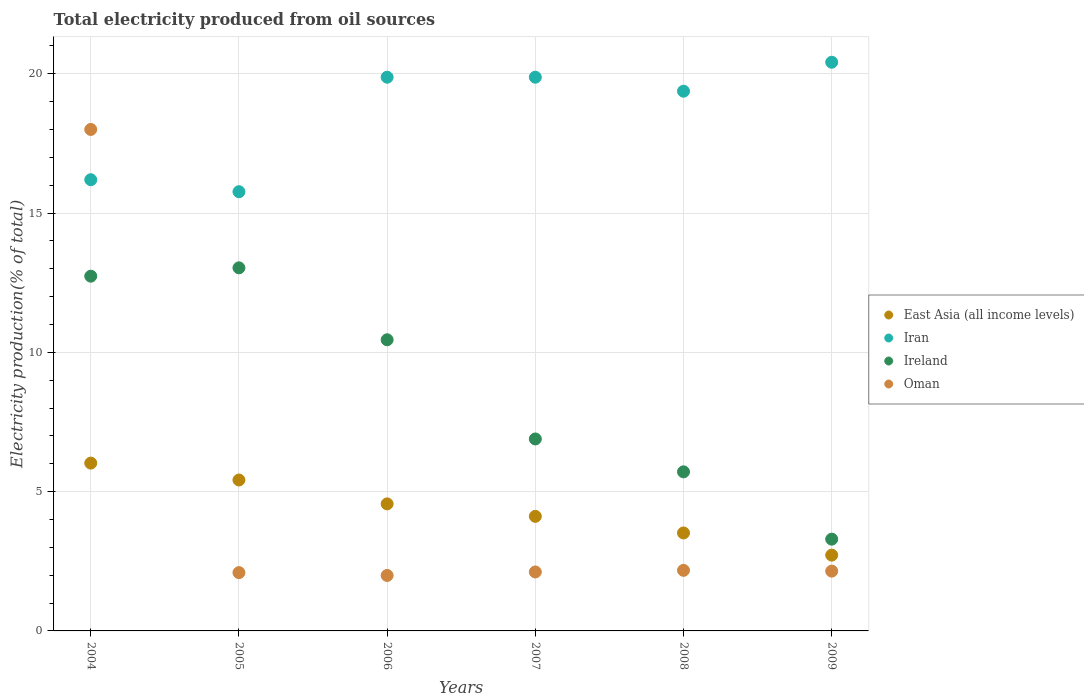What is the total electricity produced in Oman in 2009?
Provide a short and direct response. 2.15. Across all years, what is the maximum total electricity produced in Ireland?
Make the answer very short. 13.03. Across all years, what is the minimum total electricity produced in Iran?
Keep it short and to the point. 15.77. In which year was the total electricity produced in East Asia (all income levels) maximum?
Offer a terse response. 2004. In which year was the total electricity produced in Oman minimum?
Offer a very short reply. 2006. What is the total total electricity produced in Oman in the graph?
Your answer should be compact. 28.52. What is the difference between the total electricity produced in Oman in 2005 and that in 2007?
Make the answer very short. -0.02. What is the difference between the total electricity produced in Oman in 2006 and the total electricity produced in Ireland in 2009?
Your answer should be very brief. -1.3. What is the average total electricity produced in Iran per year?
Keep it short and to the point. 18.58. In the year 2007, what is the difference between the total electricity produced in Iran and total electricity produced in East Asia (all income levels)?
Provide a succinct answer. 15.76. In how many years, is the total electricity produced in Ireland greater than 2 %?
Make the answer very short. 6. What is the ratio of the total electricity produced in Iran in 2005 to that in 2009?
Provide a short and direct response. 0.77. Is the total electricity produced in Ireland in 2004 less than that in 2008?
Make the answer very short. No. What is the difference between the highest and the second highest total electricity produced in Oman?
Your answer should be compact. 15.83. What is the difference between the highest and the lowest total electricity produced in Iran?
Ensure brevity in your answer.  4.65. Is it the case that in every year, the sum of the total electricity produced in Iran and total electricity produced in East Asia (all income levels)  is greater than the total electricity produced in Oman?
Offer a very short reply. Yes. Does the total electricity produced in Iran monotonically increase over the years?
Offer a very short reply. No. Is the total electricity produced in East Asia (all income levels) strictly greater than the total electricity produced in Ireland over the years?
Your answer should be very brief. No. How many dotlines are there?
Provide a short and direct response. 4. Does the graph contain any zero values?
Provide a succinct answer. No. Does the graph contain grids?
Your response must be concise. Yes. Where does the legend appear in the graph?
Give a very brief answer. Center right. How many legend labels are there?
Keep it short and to the point. 4. How are the legend labels stacked?
Keep it short and to the point. Vertical. What is the title of the graph?
Your response must be concise. Total electricity produced from oil sources. What is the Electricity production(% of total) in East Asia (all income levels) in 2004?
Offer a very short reply. 6.02. What is the Electricity production(% of total) of Iran in 2004?
Ensure brevity in your answer.  16.2. What is the Electricity production(% of total) in Ireland in 2004?
Your answer should be compact. 12.73. What is the Electricity production(% of total) of Oman in 2004?
Your answer should be compact. 18. What is the Electricity production(% of total) of East Asia (all income levels) in 2005?
Provide a short and direct response. 5.42. What is the Electricity production(% of total) of Iran in 2005?
Keep it short and to the point. 15.77. What is the Electricity production(% of total) in Ireland in 2005?
Your response must be concise. 13.03. What is the Electricity production(% of total) in Oman in 2005?
Provide a short and direct response. 2.09. What is the Electricity production(% of total) in East Asia (all income levels) in 2006?
Offer a very short reply. 4.56. What is the Electricity production(% of total) of Iran in 2006?
Give a very brief answer. 19.88. What is the Electricity production(% of total) in Ireland in 2006?
Give a very brief answer. 10.45. What is the Electricity production(% of total) of Oman in 2006?
Provide a succinct answer. 1.99. What is the Electricity production(% of total) in East Asia (all income levels) in 2007?
Your answer should be very brief. 4.11. What is the Electricity production(% of total) of Iran in 2007?
Give a very brief answer. 19.88. What is the Electricity production(% of total) of Ireland in 2007?
Give a very brief answer. 6.89. What is the Electricity production(% of total) in Oman in 2007?
Keep it short and to the point. 2.12. What is the Electricity production(% of total) of East Asia (all income levels) in 2008?
Offer a terse response. 3.52. What is the Electricity production(% of total) in Iran in 2008?
Your answer should be very brief. 19.37. What is the Electricity production(% of total) of Ireland in 2008?
Offer a terse response. 5.71. What is the Electricity production(% of total) of Oman in 2008?
Your answer should be very brief. 2.17. What is the Electricity production(% of total) in East Asia (all income levels) in 2009?
Keep it short and to the point. 2.72. What is the Electricity production(% of total) in Iran in 2009?
Your answer should be compact. 20.41. What is the Electricity production(% of total) in Ireland in 2009?
Your answer should be very brief. 3.29. What is the Electricity production(% of total) in Oman in 2009?
Keep it short and to the point. 2.15. Across all years, what is the maximum Electricity production(% of total) of East Asia (all income levels)?
Your answer should be very brief. 6.02. Across all years, what is the maximum Electricity production(% of total) of Iran?
Give a very brief answer. 20.41. Across all years, what is the maximum Electricity production(% of total) in Ireland?
Keep it short and to the point. 13.03. Across all years, what is the maximum Electricity production(% of total) of Oman?
Give a very brief answer. 18. Across all years, what is the minimum Electricity production(% of total) of East Asia (all income levels)?
Offer a very short reply. 2.72. Across all years, what is the minimum Electricity production(% of total) of Iran?
Your answer should be very brief. 15.77. Across all years, what is the minimum Electricity production(% of total) in Ireland?
Offer a terse response. 3.29. Across all years, what is the minimum Electricity production(% of total) in Oman?
Keep it short and to the point. 1.99. What is the total Electricity production(% of total) of East Asia (all income levels) in the graph?
Provide a short and direct response. 26.35. What is the total Electricity production(% of total) of Iran in the graph?
Ensure brevity in your answer.  111.51. What is the total Electricity production(% of total) of Ireland in the graph?
Keep it short and to the point. 52.12. What is the total Electricity production(% of total) of Oman in the graph?
Make the answer very short. 28.52. What is the difference between the Electricity production(% of total) of East Asia (all income levels) in 2004 and that in 2005?
Make the answer very short. 0.61. What is the difference between the Electricity production(% of total) in Iran in 2004 and that in 2005?
Provide a succinct answer. 0.43. What is the difference between the Electricity production(% of total) of Ireland in 2004 and that in 2005?
Provide a succinct answer. -0.3. What is the difference between the Electricity production(% of total) of Oman in 2004 and that in 2005?
Your response must be concise. 15.91. What is the difference between the Electricity production(% of total) in East Asia (all income levels) in 2004 and that in 2006?
Offer a terse response. 1.46. What is the difference between the Electricity production(% of total) in Iran in 2004 and that in 2006?
Your answer should be very brief. -3.68. What is the difference between the Electricity production(% of total) of Ireland in 2004 and that in 2006?
Ensure brevity in your answer.  2.28. What is the difference between the Electricity production(% of total) of Oman in 2004 and that in 2006?
Offer a very short reply. 16.01. What is the difference between the Electricity production(% of total) in East Asia (all income levels) in 2004 and that in 2007?
Your answer should be compact. 1.91. What is the difference between the Electricity production(% of total) in Iran in 2004 and that in 2007?
Offer a very short reply. -3.68. What is the difference between the Electricity production(% of total) in Ireland in 2004 and that in 2007?
Provide a succinct answer. 5.84. What is the difference between the Electricity production(% of total) in Oman in 2004 and that in 2007?
Make the answer very short. 15.88. What is the difference between the Electricity production(% of total) of East Asia (all income levels) in 2004 and that in 2008?
Keep it short and to the point. 2.51. What is the difference between the Electricity production(% of total) in Iran in 2004 and that in 2008?
Your response must be concise. -3.18. What is the difference between the Electricity production(% of total) of Ireland in 2004 and that in 2008?
Your answer should be very brief. 7.02. What is the difference between the Electricity production(% of total) of Oman in 2004 and that in 2008?
Provide a short and direct response. 15.83. What is the difference between the Electricity production(% of total) in East Asia (all income levels) in 2004 and that in 2009?
Make the answer very short. 3.3. What is the difference between the Electricity production(% of total) of Iran in 2004 and that in 2009?
Provide a succinct answer. -4.22. What is the difference between the Electricity production(% of total) in Ireland in 2004 and that in 2009?
Keep it short and to the point. 9.44. What is the difference between the Electricity production(% of total) of Oman in 2004 and that in 2009?
Your response must be concise. 15.85. What is the difference between the Electricity production(% of total) in East Asia (all income levels) in 2005 and that in 2006?
Your answer should be compact. 0.86. What is the difference between the Electricity production(% of total) in Iran in 2005 and that in 2006?
Your answer should be compact. -4.11. What is the difference between the Electricity production(% of total) in Ireland in 2005 and that in 2006?
Keep it short and to the point. 2.58. What is the difference between the Electricity production(% of total) of Oman in 2005 and that in 2006?
Ensure brevity in your answer.  0.1. What is the difference between the Electricity production(% of total) in East Asia (all income levels) in 2005 and that in 2007?
Keep it short and to the point. 1.31. What is the difference between the Electricity production(% of total) in Iran in 2005 and that in 2007?
Your answer should be very brief. -4.11. What is the difference between the Electricity production(% of total) in Ireland in 2005 and that in 2007?
Your answer should be compact. 6.14. What is the difference between the Electricity production(% of total) in Oman in 2005 and that in 2007?
Your answer should be compact. -0.02. What is the difference between the Electricity production(% of total) of East Asia (all income levels) in 2005 and that in 2008?
Keep it short and to the point. 1.9. What is the difference between the Electricity production(% of total) of Iran in 2005 and that in 2008?
Offer a terse response. -3.61. What is the difference between the Electricity production(% of total) of Ireland in 2005 and that in 2008?
Provide a short and direct response. 7.32. What is the difference between the Electricity production(% of total) of Oman in 2005 and that in 2008?
Your answer should be compact. -0.08. What is the difference between the Electricity production(% of total) in East Asia (all income levels) in 2005 and that in 2009?
Ensure brevity in your answer.  2.7. What is the difference between the Electricity production(% of total) of Iran in 2005 and that in 2009?
Keep it short and to the point. -4.65. What is the difference between the Electricity production(% of total) of Ireland in 2005 and that in 2009?
Make the answer very short. 9.74. What is the difference between the Electricity production(% of total) of Oman in 2005 and that in 2009?
Your answer should be very brief. -0.05. What is the difference between the Electricity production(% of total) in East Asia (all income levels) in 2006 and that in 2007?
Give a very brief answer. 0.45. What is the difference between the Electricity production(% of total) of Iran in 2006 and that in 2007?
Provide a succinct answer. -0. What is the difference between the Electricity production(% of total) of Ireland in 2006 and that in 2007?
Provide a succinct answer. 3.56. What is the difference between the Electricity production(% of total) of Oman in 2006 and that in 2007?
Ensure brevity in your answer.  -0.13. What is the difference between the Electricity production(% of total) in East Asia (all income levels) in 2006 and that in 2008?
Ensure brevity in your answer.  1.04. What is the difference between the Electricity production(% of total) of Iran in 2006 and that in 2008?
Keep it short and to the point. 0.5. What is the difference between the Electricity production(% of total) in Ireland in 2006 and that in 2008?
Ensure brevity in your answer.  4.74. What is the difference between the Electricity production(% of total) in Oman in 2006 and that in 2008?
Keep it short and to the point. -0.18. What is the difference between the Electricity production(% of total) in East Asia (all income levels) in 2006 and that in 2009?
Ensure brevity in your answer.  1.84. What is the difference between the Electricity production(% of total) of Iran in 2006 and that in 2009?
Your answer should be very brief. -0.54. What is the difference between the Electricity production(% of total) in Ireland in 2006 and that in 2009?
Your answer should be very brief. 7.16. What is the difference between the Electricity production(% of total) of Oman in 2006 and that in 2009?
Make the answer very short. -0.16. What is the difference between the Electricity production(% of total) of East Asia (all income levels) in 2007 and that in 2008?
Provide a succinct answer. 0.6. What is the difference between the Electricity production(% of total) in Iran in 2007 and that in 2008?
Provide a succinct answer. 0.5. What is the difference between the Electricity production(% of total) in Ireland in 2007 and that in 2008?
Your answer should be very brief. 1.18. What is the difference between the Electricity production(% of total) in Oman in 2007 and that in 2008?
Give a very brief answer. -0.06. What is the difference between the Electricity production(% of total) in East Asia (all income levels) in 2007 and that in 2009?
Your response must be concise. 1.39. What is the difference between the Electricity production(% of total) of Iran in 2007 and that in 2009?
Provide a succinct answer. -0.54. What is the difference between the Electricity production(% of total) in Ireland in 2007 and that in 2009?
Offer a very short reply. 3.6. What is the difference between the Electricity production(% of total) of Oman in 2007 and that in 2009?
Ensure brevity in your answer.  -0.03. What is the difference between the Electricity production(% of total) of East Asia (all income levels) in 2008 and that in 2009?
Offer a terse response. 0.8. What is the difference between the Electricity production(% of total) in Iran in 2008 and that in 2009?
Offer a terse response. -1.04. What is the difference between the Electricity production(% of total) of Ireland in 2008 and that in 2009?
Ensure brevity in your answer.  2.42. What is the difference between the Electricity production(% of total) in Oman in 2008 and that in 2009?
Provide a short and direct response. 0.03. What is the difference between the Electricity production(% of total) in East Asia (all income levels) in 2004 and the Electricity production(% of total) in Iran in 2005?
Offer a terse response. -9.74. What is the difference between the Electricity production(% of total) of East Asia (all income levels) in 2004 and the Electricity production(% of total) of Ireland in 2005?
Offer a terse response. -7.01. What is the difference between the Electricity production(% of total) in East Asia (all income levels) in 2004 and the Electricity production(% of total) in Oman in 2005?
Your answer should be compact. 3.93. What is the difference between the Electricity production(% of total) in Iran in 2004 and the Electricity production(% of total) in Ireland in 2005?
Keep it short and to the point. 3.16. What is the difference between the Electricity production(% of total) in Iran in 2004 and the Electricity production(% of total) in Oman in 2005?
Ensure brevity in your answer.  14.1. What is the difference between the Electricity production(% of total) in Ireland in 2004 and the Electricity production(% of total) in Oman in 2005?
Provide a succinct answer. 10.64. What is the difference between the Electricity production(% of total) of East Asia (all income levels) in 2004 and the Electricity production(% of total) of Iran in 2006?
Provide a short and direct response. -13.85. What is the difference between the Electricity production(% of total) in East Asia (all income levels) in 2004 and the Electricity production(% of total) in Ireland in 2006?
Your answer should be very brief. -4.43. What is the difference between the Electricity production(% of total) of East Asia (all income levels) in 2004 and the Electricity production(% of total) of Oman in 2006?
Give a very brief answer. 4.03. What is the difference between the Electricity production(% of total) in Iran in 2004 and the Electricity production(% of total) in Ireland in 2006?
Offer a terse response. 5.75. What is the difference between the Electricity production(% of total) of Iran in 2004 and the Electricity production(% of total) of Oman in 2006?
Offer a terse response. 14.21. What is the difference between the Electricity production(% of total) in Ireland in 2004 and the Electricity production(% of total) in Oman in 2006?
Make the answer very short. 10.74. What is the difference between the Electricity production(% of total) of East Asia (all income levels) in 2004 and the Electricity production(% of total) of Iran in 2007?
Give a very brief answer. -13.85. What is the difference between the Electricity production(% of total) in East Asia (all income levels) in 2004 and the Electricity production(% of total) in Ireland in 2007?
Your answer should be very brief. -0.87. What is the difference between the Electricity production(% of total) of East Asia (all income levels) in 2004 and the Electricity production(% of total) of Oman in 2007?
Ensure brevity in your answer.  3.91. What is the difference between the Electricity production(% of total) of Iran in 2004 and the Electricity production(% of total) of Ireland in 2007?
Provide a succinct answer. 9.31. What is the difference between the Electricity production(% of total) in Iran in 2004 and the Electricity production(% of total) in Oman in 2007?
Your answer should be very brief. 14.08. What is the difference between the Electricity production(% of total) of Ireland in 2004 and the Electricity production(% of total) of Oman in 2007?
Keep it short and to the point. 10.62. What is the difference between the Electricity production(% of total) in East Asia (all income levels) in 2004 and the Electricity production(% of total) in Iran in 2008?
Ensure brevity in your answer.  -13.35. What is the difference between the Electricity production(% of total) of East Asia (all income levels) in 2004 and the Electricity production(% of total) of Ireland in 2008?
Provide a succinct answer. 0.31. What is the difference between the Electricity production(% of total) of East Asia (all income levels) in 2004 and the Electricity production(% of total) of Oman in 2008?
Your answer should be compact. 3.85. What is the difference between the Electricity production(% of total) of Iran in 2004 and the Electricity production(% of total) of Ireland in 2008?
Provide a succinct answer. 10.49. What is the difference between the Electricity production(% of total) of Iran in 2004 and the Electricity production(% of total) of Oman in 2008?
Give a very brief answer. 14.02. What is the difference between the Electricity production(% of total) in Ireland in 2004 and the Electricity production(% of total) in Oman in 2008?
Offer a terse response. 10.56. What is the difference between the Electricity production(% of total) of East Asia (all income levels) in 2004 and the Electricity production(% of total) of Iran in 2009?
Ensure brevity in your answer.  -14.39. What is the difference between the Electricity production(% of total) in East Asia (all income levels) in 2004 and the Electricity production(% of total) in Ireland in 2009?
Your answer should be compact. 2.73. What is the difference between the Electricity production(% of total) of East Asia (all income levels) in 2004 and the Electricity production(% of total) of Oman in 2009?
Offer a terse response. 3.88. What is the difference between the Electricity production(% of total) in Iran in 2004 and the Electricity production(% of total) in Ireland in 2009?
Provide a short and direct response. 12.9. What is the difference between the Electricity production(% of total) in Iran in 2004 and the Electricity production(% of total) in Oman in 2009?
Provide a succinct answer. 14.05. What is the difference between the Electricity production(% of total) in Ireland in 2004 and the Electricity production(% of total) in Oman in 2009?
Your answer should be compact. 10.59. What is the difference between the Electricity production(% of total) in East Asia (all income levels) in 2005 and the Electricity production(% of total) in Iran in 2006?
Keep it short and to the point. -14.46. What is the difference between the Electricity production(% of total) in East Asia (all income levels) in 2005 and the Electricity production(% of total) in Ireland in 2006?
Your answer should be compact. -5.03. What is the difference between the Electricity production(% of total) of East Asia (all income levels) in 2005 and the Electricity production(% of total) of Oman in 2006?
Make the answer very short. 3.43. What is the difference between the Electricity production(% of total) of Iran in 2005 and the Electricity production(% of total) of Ireland in 2006?
Give a very brief answer. 5.32. What is the difference between the Electricity production(% of total) of Iran in 2005 and the Electricity production(% of total) of Oman in 2006?
Give a very brief answer. 13.78. What is the difference between the Electricity production(% of total) in Ireland in 2005 and the Electricity production(% of total) in Oman in 2006?
Your answer should be compact. 11.04. What is the difference between the Electricity production(% of total) in East Asia (all income levels) in 2005 and the Electricity production(% of total) in Iran in 2007?
Give a very brief answer. -14.46. What is the difference between the Electricity production(% of total) in East Asia (all income levels) in 2005 and the Electricity production(% of total) in Ireland in 2007?
Your response must be concise. -1.47. What is the difference between the Electricity production(% of total) of East Asia (all income levels) in 2005 and the Electricity production(% of total) of Oman in 2007?
Keep it short and to the point. 3.3. What is the difference between the Electricity production(% of total) in Iran in 2005 and the Electricity production(% of total) in Ireland in 2007?
Provide a succinct answer. 8.88. What is the difference between the Electricity production(% of total) in Iran in 2005 and the Electricity production(% of total) in Oman in 2007?
Keep it short and to the point. 13.65. What is the difference between the Electricity production(% of total) of Ireland in 2005 and the Electricity production(% of total) of Oman in 2007?
Offer a very short reply. 10.92. What is the difference between the Electricity production(% of total) in East Asia (all income levels) in 2005 and the Electricity production(% of total) in Iran in 2008?
Provide a succinct answer. -13.96. What is the difference between the Electricity production(% of total) in East Asia (all income levels) in 2005 and the Electricity production(% of total) in Ireland in 2008?
Offer a very short reply. -0.29. What is the difference between the Electricity production(% of total) in East Asia (all income levels) in 2005 and the Electricity production(% of total) in Oman in 2008?
Keep it short and to the point. 3.24. What is the difference between the Electricity production(% of total) of Iran in 2005 and the Electricity production(% of total) of Ireland in 2008?
Offer a very short reply. 10.06. What is the difference between the Electricity production(% of total) of Iran in 2005 and the Electricity production(% of total) of Oman in 2008?
Your answer should be compact. 13.59. What is the difference between the Electricity production(% of total) in Ireland in 2005 and the Electricity production(% of total) in Oman in 2008?
Keep it short and to the point. 10.86. What is the difference between the Electricity production(% of total) in East Asia (all income levels) in 2005 and the Electricity production(% of total) in Iran in 2009?
Provide a succinct answer. -15. What is the difference between the Electricity production(% of total) of East Asia (all income levels) in 2005 and the Electricity production(% of total) of Ireland in 2009?
Offer a terse response. 2.12. What is the difference between the Electricity production(% of total) in East Asia (all income levels) in 2005 and the Electricity production(% of total) in Oman in 2009?
Offer a terse response. 3.27. What is the difference between the Electricity production(% of total) in Iran in 2005 and the Electricity production(% of total) in Ireland in 2009?
Offer a very short reply. 12.47. What is the difference between the Electricity production(% of total) of Iran in 2005 and the Electricity production(% of total) of Oman in 2009?
Offer a very short reply. 13.62. What is the difference between the Electricity production(% of total) of Ireland in 2005 and the Electricity production(% of total) of Oman in 2009?
Your response must be concise. 10.89. What is the difference between the Electricity production(% of total) of East Asia (all income levels) in 2006 and the Electricity production(% of total) of Iran in 2007?
Your answer should be very brief. -15.32. What is the difference between the Electricity production(% of total) in East Asia (all income levels) in 2006 and the Electricity production(% of total) in Ireland in 2007?
Offer a terse response. -2.33. What is the difference between the Electricity production(% of total) in East Asia (all income levels) in 2006 and the Electricity production(% of total) in Oman in 2007?
Ensure brevity in your answer.  2.44. What is the difference between the Electricity production(% of total) in Iran in 2006 and the Electricity production(% of total) in Ireland in 2007?
Your response must be concise. 12.99. What is the difference between the Electricity production(% of total) in Iran in 2006 and the Electricity production(% of total) in Oman in 2007?
Your answer should be compact. 17.76. What is the difference between the Electricity production(% of total) in Ireland in 2006 and the Electricity production(% of total) in Oman in 2007?
Ensure brevity in your answer.  8.33. What is the difference between the Electricity production(% of total) of East Asia (all income levels) in 2006 and the Electricity production(% of total) of Iran in 2008?
Your answer should be very brief. -14.81. What is the difference between the Electricity production(% of total) in East Asia (all income levels) in 2006 and the Electricity production(% of total) in Ireland in 2008?
Provide a short and direct response. -1.15. What is the difference between the Electricity production(% of total) in East Asia (all income levels) in 2006 and the Electricity production(% of total) in Oman in 2008?
Your answer should be compact. 2.39. What is the difference between the Electricity production(% of total) in Iran in 2006 and the Electricity production(% of total) in Ireland in 2008?
Provide a succinct answer. 14.17. What is the difference between the Electricity production(% of total) in Iran in 2006 and the Electricity production(% of total) in Oman in 2008?
Your answer should be very brief. 17.7. What is the difference between the Electricity production(% of total) of Ireland in 2006 and the Electricity production(% of total) of Oman in 2008?
Keep it short and to the point. 8.28. What is the difference between the Electricity production(% of total) of East Asia (all income levels) in 2006 and the Electricity production(% of total) of Iran in 2009?
Your answer should be very brief. -15.85. What is the difference between the Electricity production(% of total) of East Asia (all income levels) in 2006 and the Electricity production(% of total) of Ireland in 2009?
Make the answer very short. 1.27. What is the difference between the Electricity production(% of total) in East Asia (all income levels) in 2006 and the Electricity production(% of total) in Oman in 2009?
Keep it short and to the point. 2.41. What is the difference between the Electricity production(% of total) of Iran in 2006 and the Electricity production(% of total) of Ireland in 2009?
Your response must be concise. 16.58. What is the difference between the Electricity production(% of total) in Iran in 2006 and the Electricity production(% of total) in Oman in 2009?
Ensure brevity in your answer.  17.73. What is the difference between the Electricity production(% of total) in Ireland in 2006 and the Electricity production(% of total) in Oman in 2009?
Your response must be concise. 8.3. What is the difference between the Electricity production(% of total) of East Asia (all income levels) in 2007 and the Electricity production(% of total) of Iran in 2008?
Your response must be concise. -15.26. What is the difference between the Electricity production(% of total) in East Asia (all income levels) in 2007 and the Electricity production(% of total) in Ireland in 2008?
Provide a short and direct response. -1.6. What is the difference between the Electricity production(% of total) in East Asia (all income levels) in 2007 and the Electricity production(% of total) in Oman in 2008?
Offer a very short reply. 1.94. What is the difference between the Electricity production(% of total) of Iran in 2007 and the Electricity production(% of total) of Ireland in 2008?
Your response must be concise. 14.17. What is the difference between the Electricity production(% of total) in Iran in 2007 and the Electricity production(% of total) in Oman in 2008?
Ensure brevity in your answer.  17.7. What is the difference between the Electricity production(% of total) of Ireland in 2007 and the Electricity production(% of total) of Oman in 2008?
Make the answer very short. 4.72. What is the difference between the Electricity production(% of total) of East Asia (all income levels) in 2007 and the Electricity production(% of total) of Iran in 2009?
Make the answer very short. -16.3. What is the difference between the Electricity production(% of total) of East Asia (all income levels) in 2007 and the Electricity production(% of total) of Ireland in 2009?
Give a very brief answer. 0.82. What is the difference between the Electricity production(% of total) in East Asia (all income levels) in 2007 and the Electricity production(% of total) in Oman in 2009?
Provide a succinct answer. 1.97. What is the difference between the Electricity production(% of total) in Iran in 2007 and the Electricity production(% of total) in Ireland in 2009?
Provide a short and direct response. 16.58. What is the difference between the Electricity production(% of total) in Iran in 2007 and the Electricity production(% of total) in Oman in 2009?
Your answer should be very brief. 17.73. What is the difference between the Electricity production(% of total) in Ireland in 2007 and the Electricity production(% of total) in Oman in 2009?
Your answer should be compact. 4.74. What is the difference between the Electricity production(% of total) in East Asia (all income levels) in 2008 and the Electricity production(% of total) in Iran in 2009?
Your answer should be very brief. -16.9. What is the difference between the Electricity production(% of total) in East Asia (all income levels) in 2008 and the Electricity production(% of total) in Ireland in 2009?
Provide a short and direct response. 0.22. What is the difference between the Electricity production(% of total) in East Asia (all income levels) in 2008 and the Electricity production(% of total) in Oman in 2009?
Make the answer very short. 1.37. What is the difference between the Electricity production(% of total) in Iran in 2008 and the Electricity production(% of total) in Ireland in 2009?
Give a very brief answer. 16.08. What is the difference between the Electricity production(% of total) of Iran in 2008 and the Electricity production(% of total) of Oman in 2009?
Ensure brevity in your answer.  17.23. What is the difference between the Electricity production(% of total) in Ireland in 2008 and the Electricity production(% of total) in Oman in 2009?
Offer a very short reply. 3.56. What is the average Electricity production(% of total) of East Asia (all income levels) per year?
Your answer should be very brief. 4.39. What is the average Electricity production(% of total) of Iran per year?
Ensure brevity in your answer.  18.58. What is the average Electricity production(% of total) in Ireland per year?
Offer a very short reply. 8.69. What is the average Electricity production(% of total) in Oman per year?
Your response must be concise. 4.75. In the year 2004, what is the difference between the Electricity production(% of total) of East Asia (all income levels) and Electricity production(% of total) of Iran?
Provide a short and direct response. -10.17. In the year 2004, what is the difference between the Electricity production(% of total) in East Asia (all income levels) and Electricity production(% of total) in Ireland?
Provide a short and direct response. -6.71. In the year 2004, what is the difference between the Electricity production(% of total) in East Asia (all income levels) and Electricity production(% of total) in Oman?
Ensure brevity in your answer.  -11.98. In the year 2004, what is the difference between the Electricity production(% of total) in Iran and Electricity production(% of total) in Ireland?
Keep it short and to the point. 3.46. In the year 2004, what is the difference between the Electricity production(% of total) in Iran and Electricity production(% of total) in Oman?
Offer a very short reply. -1.8. In the year 2004, what is the difference between the Electricity production(% of total) in Ireland and Electricity production(% of total) in Oman?
Make the answer very short. -5.27. In the year 2005, what is the difference between the Electricity production(% of total) of East Asia (all income levels) and Electricity production(% of total) of Iran?
Offer a very short reply. -10.35. In the year 2005, what is the difference between the Electricity production(% of total) in East Asia (all income levels) and Electricity production(% of total) in Ireland?
Make the answer very short. -7.62. In the year 2005, what is the difference between the Electricity production(% of total) in East Asia (all income levels) and Electricity production(% of total) in Oman?
Your response must be concise. 3.33. In the year 2005, what is the difference between the Electricity production(% of total) of Iran and Electricity production(% of total) of Ireland?
Keep it short and to the point. 2.73. In the year 2005, what is the difference between the Electricity production(% of total) in Iran and Electricity production(% of total) in Oman?
Keep it short and to the point. 13.67. In the year 2005, what is the difference between the Electricity production(% of total) of Ireland and Electricity production(% of total) of Oman?
Give a very brief answer. 10.94. In the year 2006, what is the difference between the Electricity production(% of total) in East Asia (all income levels) and Electricity production(% of total) in Iran?
Provide a short and direct response. -15.32. In the year 2006, what is the difference between the Electricity production(% of total) in East Asia (all income levels) and Electricity production(% of total) in Ireland?
Provide a short and direct response. -5.89. In the year 2006, what is the difference between the Electricity production(% of total) of East Asia (all income levels) and Electricity production(% of total) of Oman?
Keep it short and to the point. 2.57. In the year 2006, what is the difference between the Electricity production(% of total) in Iran and Electricity production(% of total) in Ireland?
Give a very brief answer. 9.43. In the year 2006, what is the difference between the Electricity production(% of total) in Iran and Electricity production(% of total) in Oman?
Give a very brief answer. 17.89. In the year 2006, what is the difference between the Electricity production(% of total) of Ireland and Electricity production(% of total) of Oman?
Offer a very short reply. 8.46. In the year 2007, what is the difference between the Electricity production(% of total) of East Asia (all income levels) and Electricity production(% of total) of Iran?
Offer a very short reply. -15.76. In the year 2007, what is the difference between the Electricity production(% of total) of East Asia (all income levels) and Electricity production(% of total) of Ireland?
Offer a terse response. -2.78. In the year 2007, what is the difference between the Electricity production(% of total) in East Asia (all income levels) and Electricity production(% of total) in Oman?
Your answer should be compact. 2. In the year 2007, what is the difference between the Electricity production(% of total) in Iran and Electricity production(% of total) in Ireland?
Ensure brevity in your answer.  12.99. In the year 2007, what is the difference between the Electricity production(% of total) of Iran and Electricity production(% of total) of Oman?
Your response must be concise. 17.76. In the year 2007, what is the difference between the Electricity production(% of total) of Ireland and Electricity production(% of total) of Oman?
Keep it short and to the point. 4.77. In the year 2008, what is the difference between the Electricity production(% of total) in East Asia (all income levels) and Electricity production(% of total) in Iran?
Give a very brief answer. -15.86. In the year 2008, what is the difference between the Electricity production(% of total) of East Asia (all income levels) and Electricity production(% of total) of Ireland?
Offer a very short reply. -2.19. In the year 2008, what is the difference between the Electricity production(% of total) in East Asia (all income levels) and Electricity production(% of total) in Oman?
Ensure brevity in your answer.  1.34. In the year 2008, what is the difference between the Electricity production(% of total) in Iran and Electricity production(% of total) in Ireland?
Your answer should be very brief. 13.66. In the year 2008, what is the difference between the Electricity production(% of total) in Iran and Electricity production(% of total) in Oman?
Keep it short and to the point. 17.2. In the year 2008, what is the difference between the Electricity production(% of total) in Ireland and Electricity production(% of total) in Oman?
Provide a short and direct response. 3.54. In the year 2009, what is the difference between the Electricity production(% of total) of East Asia (all income levels) and Electricity production(% of total) of Iran?
Offer a very short reply. -17.69. In the year 2009, what is the difference between the Electricity production(% of total) of East Asia (all income levels) and Electricity production(% of total) of Ireland?
Ensure brevity in your answer.  -0.57. In the year 2009, what is the difference between the Electricity production(% of total) of East Asia (all income levels) and Electricity production(% of total) of Oman?
Your answer should be compact. 0.57. In the year 2009, what is the difference between the Electricity production(% of total) in Iran and Electricity production(% of total) in Ireland?
Your answer should be compact. 17.12. In the year 2009, what is the difference between the Electricity production(% of total) in Iran and Electricity production(% of total) in Oman?
Your response must be concise. 18.27. In the year 2009, what is the difference between the Electricity production(% of total) in Ireland and Electricity production(% of total) in Oman?
Give a very brief answer. 1.15. What is the ratio of the Electricity production(% of total) of East Asia (all income levels) in 2004 to that in 2005?
Ensure brevity in your answer.  1.11. What is the ratio of the Electricity production(% of total) of Iran in 2004 to that in 2005?
Keep it short and to the point. 1.03. What is the ratio of the Electricity production(% of total) in Oman in 2004 to that in 2005?
Keep it short and to the point. 8.6. What is the ratio of the Electricity production(% of total) in East Asia (all income levels) in 2004 to that in 2006?
Ensure brevity in your answer.  1.32. What is the ratio of the Electricity production(% of total) in Iran in 2004 to that in 2006?
Keep it short and to the point. 0.81. What is the ratio of the Electricity production(% of total) in Ireland in 2004 to that in 2006?
Offer a terse response. 1.22. What is the ratio of the Electricity production(% of total) in Oman in 2004 to that in 2006?
Ensure brevity in your answer.  9.04. What is the ratio of the Electricity production(% of total) of East Asia (all income levels) in 2004 to that in 2007?
Offer a terse response. 1.46. What is the ratio of the Electricity production(% of total) in Iran in 2004 to that in 2007?
Ensure brevity in your answer.  0.81. What is the ratio of the Electricity production(% of total) of Ireland in 2004 to that in 2007?
Your response must be concise. 1.85. What is the ratio of the Electricity production(% of total) in Oman in 2004 to that in 2007?
Provide a succinct answer. 8.5. What is the ratio of the Electricity production(% of total) in East Asia (all income levels) in 2004 to that in 2008?
Offer a very short reply. 1.71. What is the ratio of the Electricity production(% of total) of Iran in 2004 to that in 2008?
Provide a short and direct response. 0.84. What is the ratio of the Electricity production(% of total) of Ireland in 2004 to that in 2008?
Ensure brevity in your answer.  2.23. What is the ratio of the Electricity production(% of total) of Oman in 2004 to that in 2008?
Offer a very short reply. 8.28. What is the ratio of the Electricity production(% of total) in East Asia (all income levels) in 2004 to that in 2009?
Your answer should be compact. 2.21. What is the ratio of the Electricity production(% of total) in Iran in 2004 to that in 2009?
Your response must be concise. 0.79. What is the ratio of the Electricity production(% of total) of Ireland in 2004 to that in 2009?
Offer a terse response. 3.87. What is the ratio of the Electricity production(% of total) in Oman in 2004 to that in 2009?
Make the answer very short. 8.38. What is the ratio of the Electricity production(% of total) of East Asia (all income levels) in 2005 to that in 2006?
Provide a short and direct response. 1.19. What is the ratio of the Electricity production(% of total) of Iran in 2005 to that in 2006?
Ensure brevity in your answer.  0.79. What is the ratio of the Electricity production(% of total) of Ireland in 2005 to that in 2006?
Provide a succinct answer. 1.25. What is the ratio of the Electricity production(% of total) of Oman in 2005 to that in 2006?
Provide a succinct answer. 1.05. What is the ratio of the Electricity production(% of total) in East Asia (all income levels) in 2005 to that in 2007?
Provide a short and direct response. 1.32. What is the ratio of the Electricity production(% of total) of Iran in 2005 to that in 2007?
Offer a very short reply. 0.79. What is the ratio of the Electricity production(% of total) in Ireland in 2005 to that in 2007?
Keep it short and to the point. 1.89. What is the ratio of the Electricity production(% of total) of Oman in 2005 to that in 2007?
Your answer should be very brief. 0.99. What is the ratio of the Electricity production(% of total) in East Asia (all income levels) in 2005 to that in 2008?
Provide a short and direct response. 1.54. What is the ratio of the Electricity production(% of total) in Iran in 2005 to that in 2008?
Give a very brief answer. 0.81. What is the ratio of the Electricity production(% of total) in Ireland in 2005 to that in 2008?
Your answer should be very brief. 2.28. What is the ratio of the Electricity production(% of total) of Oman in 2005 to that in 2008?
Offer a terse response. 0.96. What is the ratio of the Electricity production(% of total) of East Asia (all income levels) in 2005 to that in 2009?
Your response must be concise. 1.99. What is the ratio of the Electricity production(% of total) in Iran in 2005 to that in 2009?
Give a very brief answer. 0.77. What is the ratio of the Electricity production(% of total) in Ireland in 2005 to that in 2009?
Your response must be concise. 3.96. What is the ratio of the Electricity production(% of total) of Oman in 2005 to that in 2009?
Provide a short and direct response. 0.97. What is the ratio of the Electricity production(% of total) of East Asia (all income levels) in 2006 to that in 2007?
Offer a terse response. 1.11. What is the ratio of the Electricity production(% of total) in Iran in 2006 to that in 2007?
Keep it short and to the point. 1. What is the ratio of the Electricity production(% of total) of Ireland in 2006 to that in 2007?
Make the answer very short. 1.52. What is the ratio of the Electricity production(% of total) of Oman in 2006 to that in 2007?
Provide a succinct answer. 0.94. What is the ratio of the Electricity production(% of total) in East Asia (all income levels) in 2006 to that in 2008?
Offer a terse response. 1.3. What is the ratio of the Electricity production(% of total) of Iran in 2006 to that in 2008?
Provide a short and direct response. 1.03. What is the ratio of the Electricity production(% of total) in Ireland in 2006 to that in 2008?
Your answer should be very brief. 1.83. What is the ratio of the Electricity production(% of total) of Oman in 2006 to that in 2008?
Make the answer very short. 0.92. What is the ratio of the Electricity production(% of total) of East Asia (all income levels) in 2006 to that in 2009?
Give a very brief answer. 1.68. What is the ratio of the Electricity production(% of total) in Iran in 2006 to that in 2009?
Your answer should be very brief. 0.97. What is the ratio of the Electricity production(% of total) in Ireland in 2006 to that in 2009?
Your answer should be compact. 3.17. What is the ratio of the Electricity production(% of total) in Oman in 2006 to that in 2009?
Ensure brevity in your answer.  0.93. What is the ratio of the Electricity production(% of total) of East Asia (all income levels) in 2007 to that in 2008?
Provide a succinct answer. 1.17. What is the ratio of the Electricity production(% of total) of Iran in 2007 to that in 2008?
Provide a short and direct response. 1.03. What is the ratio of the Electricity production(% of total) in Ireland in 2007 to that in 2008?
Offer a terse response. 1.21. What is the ratio of the Electricity production(% of total) in Oman in 2007 to that in 2008?
Keep it short and to the point. 0.97. What is the ratio of the Electricity production(% of total) of East Asia (all income levels) in 2007 to that in 2009?
Offer a very short reply. 1.51. What is the ratio of the Electricity production(% of total) in Iran in 2007 to that in 2009?
Keep it short and to the point. 0.97. What is the ratio of the Electricity production(% of total) in Ireland in 2007 to that in 2009?
Make the answer very short. 2.09. What is the ratio of the Electricity production(% of total) in Oman in 2007 to that in 2009?
Keep it short and to the point. 0.99. What is the ratio of the Electricity production(% of total) in East Asia (all income levels) in 2008 to that in 2009?
Your answer should be very brief. 1.29. What is the ratio of the Electricity production(% of total) in Iran in 2008 to that in 2009?
Your answer should be very brief. 0.95. What is the ratio of the Electricity production(% of total) in Ireland in 2008 to that in 2009?
Make the answer very short. 1.73. What is the ratio of the Electricity production(% of total) of Oman in 2008 to that in 2009?
Provide a short and direct response. 1.01. What is the difference between the highest and the second highest Electricity production(% of total) of East Asia (all income levels)?
Provide a succinct answer. 0.61. What is the difference between the highest and the second highest Electricity production(% of total) in Iran?
Provide a short and direct response. 0.54. What is the difference between the highest and the second highest Electricity production(% of total) in Ireland?
Offer a terse response. 0.3. What is the difference between the highest and the second highest Electricity production(% of total) in Oman?
Give a very brief answer. 15.83. What is the difference between the highest and the lowest Electricity production(% of total) in East Asia (all income levels)?
Your answer should be compact. 3.3. What is the difference between the highest and the lowest Electricity production(% of total) of Iran?
Your response must be concise. 4.65. What is the difference between the highest and the lowest Electricity production(% of total) of Ireland?
Ensure brevity in your answer.  9.74. What is the difference between the highest and the lowest Electricity production(% of total) in Oman?
Your answer should be compact. 16.01. 